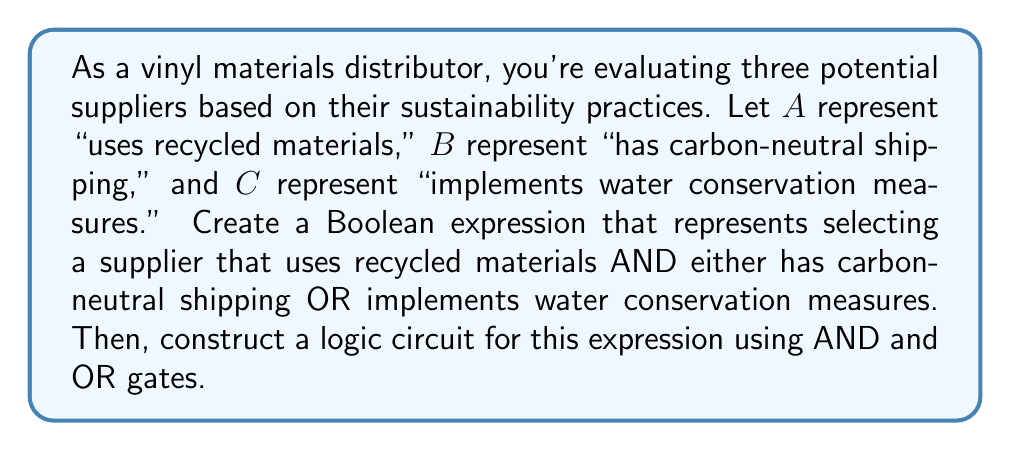Can you solve this math problem? 1. First, let's translate the given conditions into a Boolean expression:
   We want A AND (B OR C)
   This can be written as: $A \cdot (B + C)$

2. To construct the logic circuit, we'll use the following steps:
   a. Start with inputs A, B, and C
   b. Use an OR gate for (B + C)
   c. Use an AND gate to combine A with the result of (B + C)

3. The logic circuit can be represented as follows:

[asy]
import geometry;

pair A = (0,80), B = (0,40), C = (0,0);
pair OR = (60,20), AND = (120,50);
pair OUT = (180,50);

draw(A--OR, arrow=Arrow(SimpleHead));
draw(B--OR, arrow=Arrow(SimpleHead));
draw(C--OR, arrow=Arrow(SimpleHead));
draw(OR--AND, arrow=Arrow(SimpleHead));
draw(A--(60,80)--(120,80)--AND, arrow=Arrow(SimpleHead));
draw(AND--OUT, arrow=Arrow(SimpleHead));

label("A", A, W);
label("B", B, W);
label("C", C, W);
label("OR", OR, E);
label("AND", AND, E);
label("Output", OUT, E);

draw(circle(OR,15));
draw(circle(AND,15));

label("≥1", OR, fontsize(8));
label("&", AND, fontsize(10));
[/asy]

4. This circuit implements the Boolean expression $A \cdot (B + C)$, which represents selecting a supplier that uses recycled materials (A) AND either has carbon-neutral shipping (B) OR implements water conservation measures (C).
Answer: $A \cdot (B + C)$ 